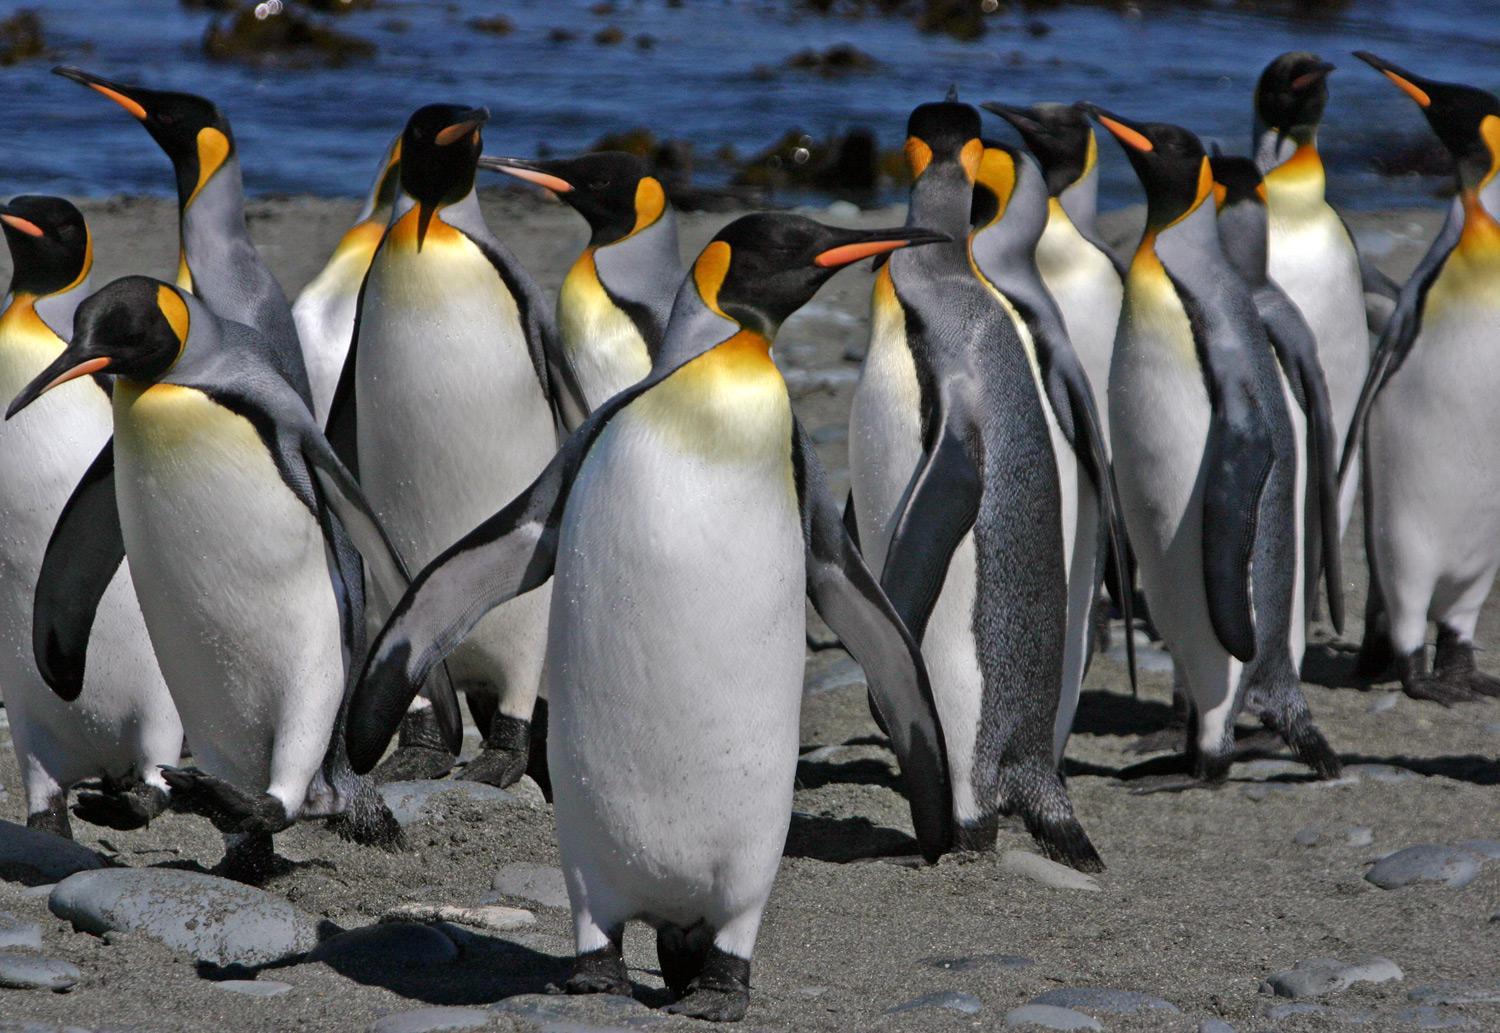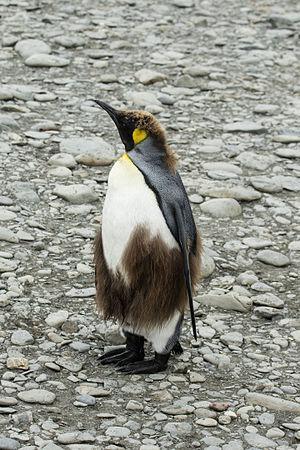The first image is the image on the left, the second image is the image on the right. Considering the images on both sides, is "2 penguins are facing each other with chests almost touching" valid? Answer yes or no. No. The first image is the image on the left, the second image is the image on the right. Examine the images to the left and right. Is the description "There are exactly three penguins." accurate? Answer yes or no. No. 